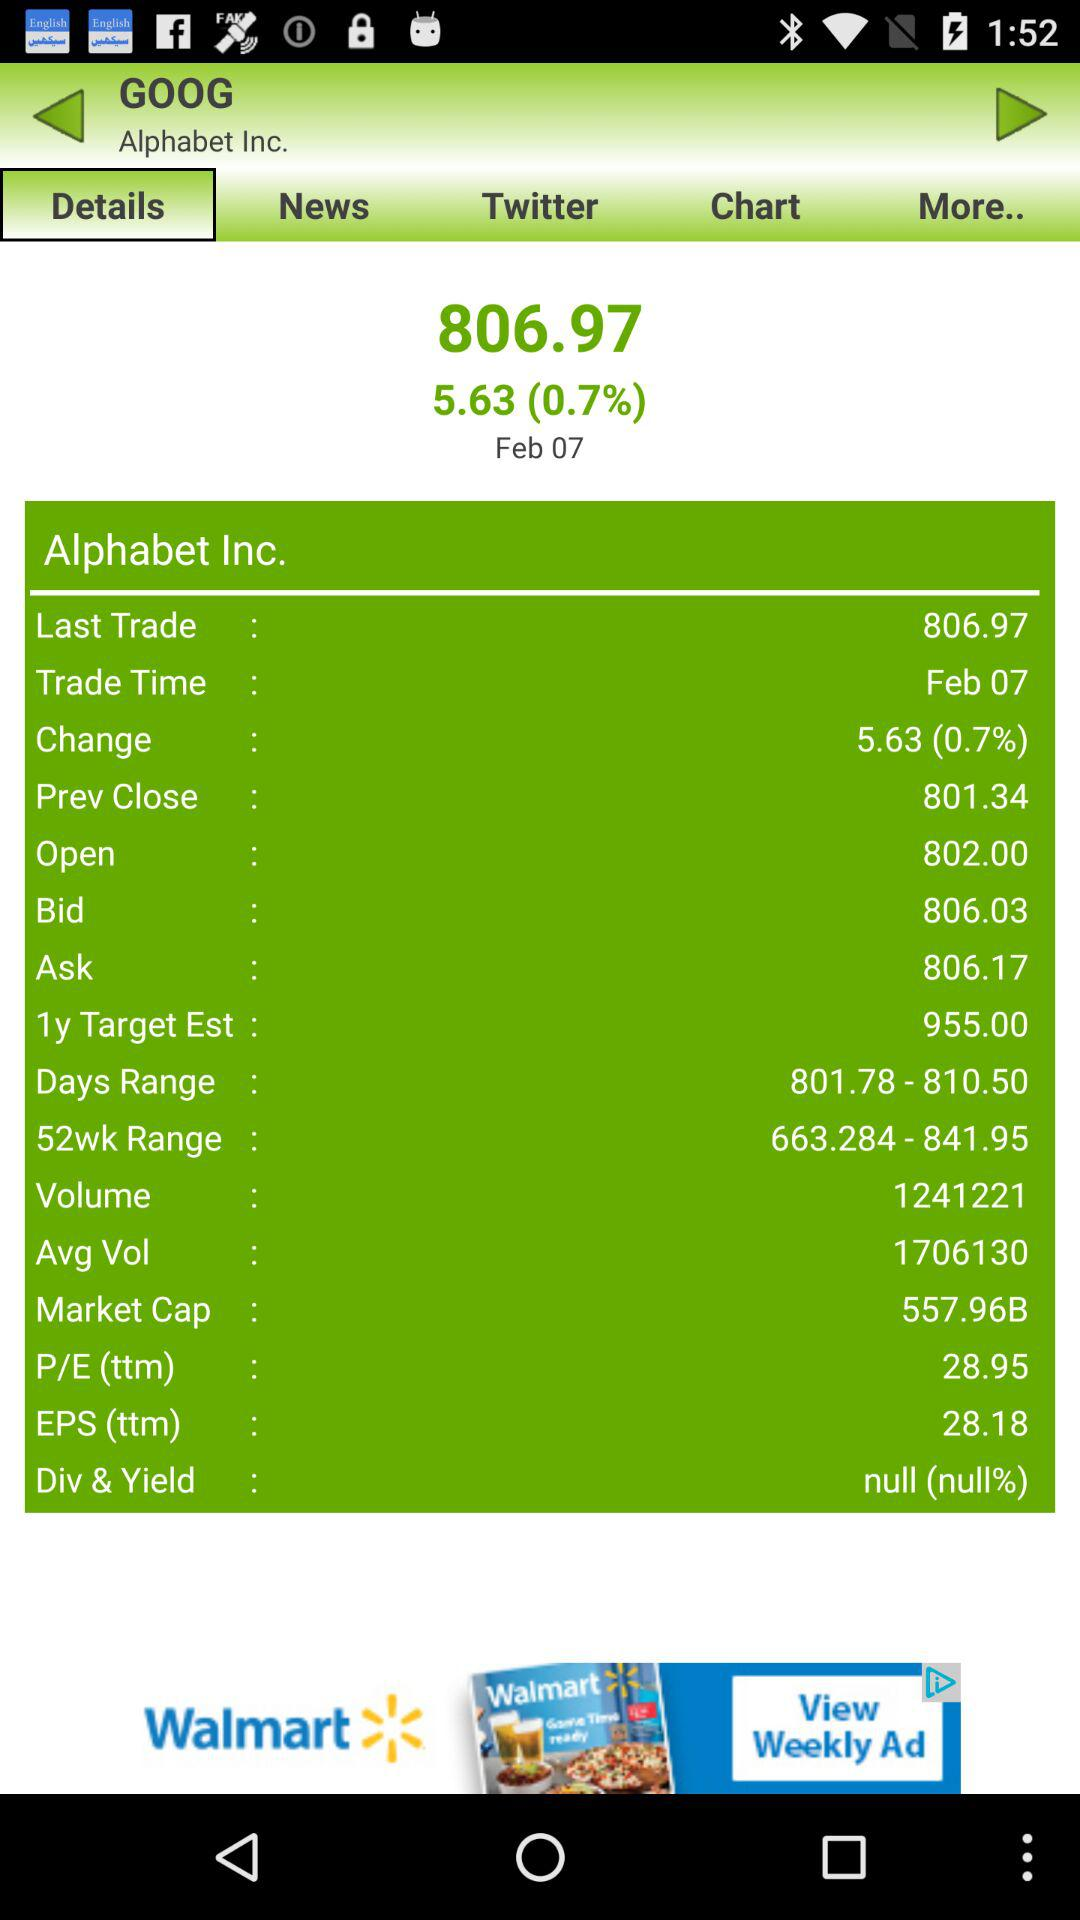What is the volume of "Alphabet Inc."? The volume of "Alphabet Inc." is 1241221. 